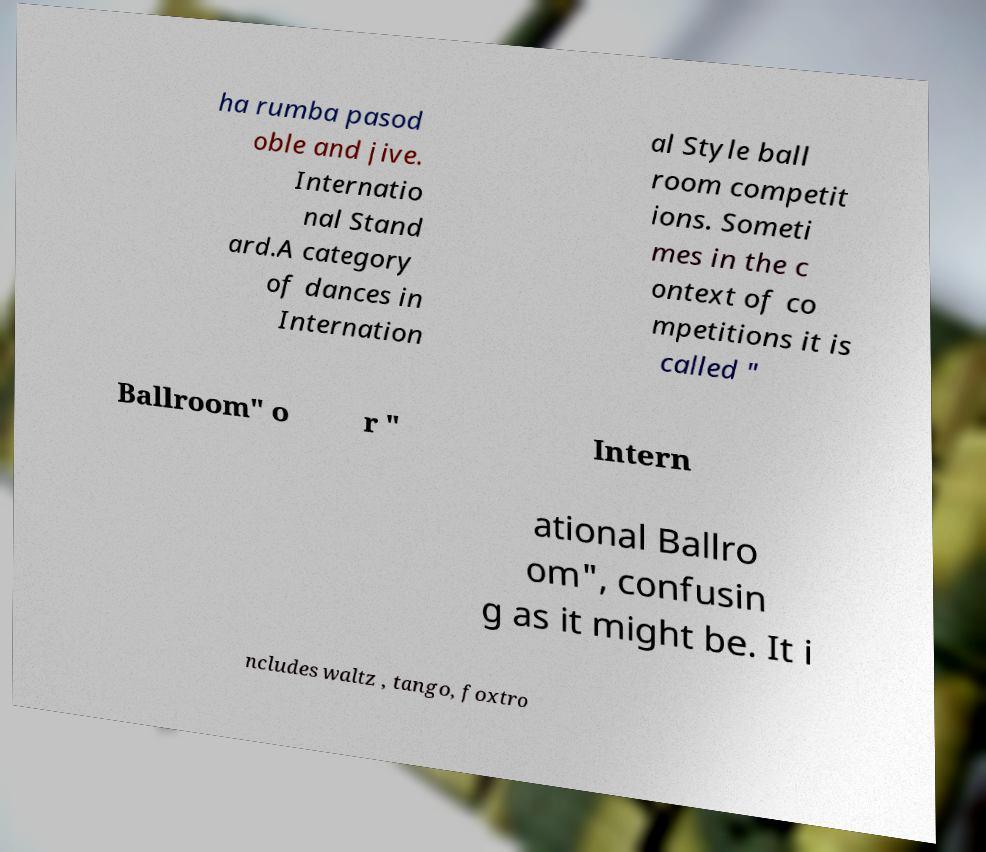Can you accurately transcribe the text from the provided image for me? Certainly! The text on the image appears to be about dance categories and reads as follows: 'Cha rumba pasodoble and jive. International Standard. A category of dances in International Style ballroom competitions. Sometimes in the context of competitions, it is called "Ballroom" or "International Ballroom", confusing as it might be. It includes waltz, tango, foxtrot.' Please note that the text may contain a few transcription errors due to the breaks in the text on the image. 